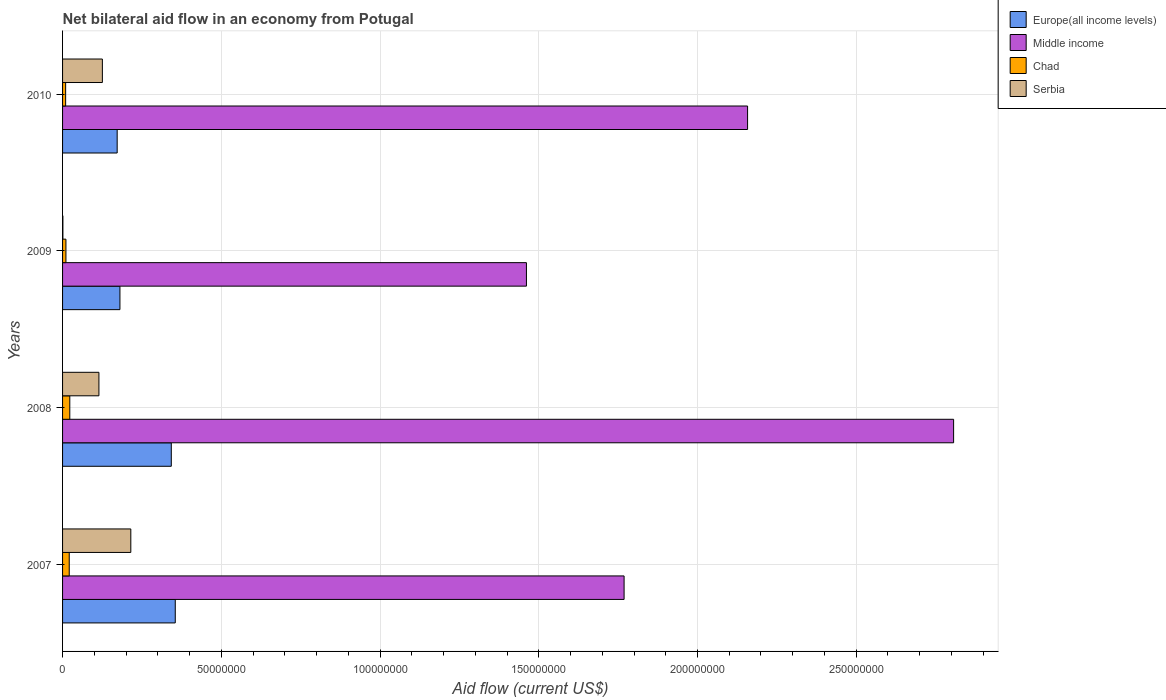Are the number of bars per tick equal to the number of legend labels?
Provide a short and direct response. Yes. How many bars are there on the 4th tick from the bottom?
Make the answer very short. 4. In how many cases, is the number of bars for a given year not equal to the number of legend labels?
Give a very brief answer. 0. What is the net bilateral aid flow in Middle income in 2007?
Make the answer very short. 1.77e+08. Across all years, what is the maximum net bilateral aid flow in Serbia?
Give a very brief answer. 2.15e+07. Across all years, what is the minimum net bilateral aid flow in Serbia?
Make the answer very short. 1.00e+05. In which year was the net bilateral aid flow in Europe(all income levels) maximum?
Ensure brevity in your answer.  2007. What is the total net bilateral aid flow in Serbia in the graph?
Make the answer very short. 4.56e+07. What is the difference between the net bilateral aid flow in Europe(all income levels) in 2007 and that in 2008?
Offer a terse response. 1.25e+06. What is the difference between the net bilateral aid flow in Serbia in 2009 and the net bilateral aid flow in Europe(all income levels) in 2007?
Provide a short and direct response. -3.54e+07. What is the average net bilateral aid flow in Chad per year?
Provide a succinct answer. 1.60e+06. In the year 2009, what is the difference between the net bilateral aid flow in Europe(all income levels) and net bilateral aid flow in Chad?
Provide a succinct answer. 1.70e+07. What is the ratio of the net bilateral aid flow in Europe(all income levels) in 2007 to that in 2009?
Provide a short and direct response. 1.96. Is the net bilateral aid flow in Chad in 2007 less than that in 2010?
Make the answer very short. No. Is the difference between the net bilateral aid flow in Europe(all income levels) in 2007 and 2008 greater than the difference between the net bilateral aid flow in Chad in 2007 and 2008?
Offer a very short reply. Yes. What is the difference between the highest and the second highest net bilateral aid flow in Middle income?
Ensure brevity in your answer.  6.49e+07. What is the difference between the highest and the lowest net bilateral aid flow in Europe(all income levels)?
Your answer should be very brief. 1.83e+07. In how many years, is the net bilateral aid flow in Europe(all income levels) greater than the average net bilateral aid flow in Europe(all income levels) taken over all years?
Your answer should be compact. 2. What does the 2nd bar from the top in 2008 represents?
Your response must be concise. Chad. What does the 2nd bar from the bottom in 2009 represents?
Ensure brevity in your answer.  Middle income. Is it the case that in every year, the sum of the net bilateral aid flow in Chad and net bilateral aid flow in Europe(all income levels) is greater than the net bilateral aid flow in Middle income?
Provide a short and direct response. No. What is the difference between two consecutive major ticks on the X-axis?
Offer a terse response. 5.00e+07. Does the graph contain grids?
Give a very brief answer. Yes. Where does the legend appear in the graph?
Provide a short and direct response. Top right. How are the legend labels stacked?
Provide a succinct answer. Vertical. What is the title of the graph?
Make the answer very short. Net bilateral aid flow in an economy from Potugal. Does "American Samoa" appear as one of the legend labels in the graph?
Your answer should be very brief. No. What is the label or title of the X-axis?
Your answer should be compact. Aid flow (current US$). What is the Aid flow (current US$) of Europe(all income levels) in 2007?
Offer a terse response. 3.55e+07. What is the Aid flow (current US$) in Middle income in 2007?
Offer a terse response. 1.77e+08. What is the Aid flow (current US$) of Chad in 2007?
Give a very brief answer. 2.10e+06. What is the Aid flow (current US$) in Serbia in 2007?
Your answer should be very brief. 2.15e+07. What is the Aid flow (current US$) of Europe(all income levels) in 2008?
Ensure brevity in your answer.  3.42e+07. What is the Aid flow (current US$) of Middle income in 2008?
Give a very brief answer. 2.81e+08. What is the Aid flow (current US$) in Chad in 2008?
Your answer should be compact. 2.28e+06. What is the Aid flow (current US$) in Serbia in 2008?
Offer a terse response. 1.14e+07. What is the Aid flow (current US$) in Europe(all income levels) in 2009?
Offer a terse response. 1.81e+07. What is the Aid flow (current US$) in Middle income in 2009?
Make the answer very short. 1.46e+08. What is the Aid flow (current US$) in Chad in 2009?
Offer a terse response. 1.06e+06. What is the Aid flow (current US$) of Europe(all income levels) in 2010?
Keep it short and to the point. 1.72e+07. What is the Aid flow (current US$) in Middle income in 2010?
Ensure brevity in your answer.  2.16e+08. What is the Aid flow (current US$) in Chad in 2010?
Make the answer very short. 9.70e+05. What is the Aid flow (current US$) in Serbia in 2010?
Your answer should be compact. 1.25e+07. Across all years, what is the maximum Aid flow (current US$) in Europe(all income levels)?
Your answer should be compact. 3.55e+07. Across all years, what is the maximum Aid flow (current US$) of Middle income?
Offer a very short reply. 2.81e+08. Across all years, what is the maximum Aid flow (current US$) in Chad?
Give a very brief answer. 2.28e+06. Across all years, what is the maximum Aid flow (current US$) of Serbia?
Keep it short and to the point. 2.15e+07. Across all years, what is the minimum Aid flow (current US$) in Europe(all income levels)?
Provide a succinct answer. 1.72e+07. Across all years, what is the minimum Aid flow (current US$) of Middle income?
Provide a short and direct response. 1.46e+08. Across all years, what is the minimum Aid flow (current US$) in Chad?
Your response must be concise. 9.70e+05. What is the total Aid flow (current US$) of Europe(all income levels) in the graph?
Your answer should be very brief. 1.05e+08. What is the total Aid flow (current US$) of Middle income in the graph?
Keep it short and to the point. 8.19e+08. What is the total Aid flow (current US$) of Chad in the graph?
Provide a short and direct response. 6.41e+06. What is the total Aid flow (current US$) in Serbia in the graph?
Make the answer very short. 4.56e+07. What is the difference between the Aid flow (current US$) in Europe(all income levels) in 2007 and that in 2008?
Your answer should be compact. 1.25e+06. What is the difference between the Aid flow (current US$) of Middle income in 2007 and that in 2008?
Give a very brief answer. -1.04e+08. What is the difference between the Aid flow (current US$) in Serbia in 2007 and that in 2008?
Your answer should be very brief. 1.00e+07. What is the difference between the Aid flow (current US$) of Europe(all income levels) in 2007 and that in 2009?
Make the answer very short. 1.74e+07. What is the difference between the Aid flow (current US$) in Middle income in 2007 and that in 2009?
Your answer should be compact. 3.08e+07. What is the difference between the Aid flow (current US$) in Chad in 2007 and that in 2009?
Keep it short and to the point. 1.04e+06. What is the difference between the Aid flow (current US$) in Serbia in 2007 and that in 2009?
Offer a very short reply. 2.14e+07. What is the difference between the Aid flow (current US$) of Europe(all income levels) in 2007 and that in 2010?
Your answer should be very brief. 1.83e+07. What is the difference between the Aid flow (current US$) in Middle income in 2007 and that in 2010?
Offer a terse response. -3.89e+07. What is the difference between the Aid flow (current US$) in Chad in 2007 and that in 2010?
Ensure brevity in your answer.  1.13e+06. What is the difference between the Aid flow (current US$) in Serbia in 2007 and that in 2010?
Your answer should be very brief. 8.96e+06. What is the difference between the Aid flow (current US$) in Europe(all income levels) in 2008 and that in 2009?
Keep it short and to the point. 1.62e+07. What is the difference between the Aid flow (current US$) in Middle income in 2008 and that in 2009?
Ensure brevity in your answer.  1.35e+08. What is the difference between the Aid flow (current US$) in Chad in 2008 and that in 2009?
Your answer should be very brief. 1.22e+06. What is the difference between the Aid flow (current US$) of Serbia in 2008 and that in 2009?
Make the answer very short. 1.14e+07. What is the difference between the Aid flow (current US$) in Europe(all income levels) in 2008 and that in 2010?
Give a very brief answer. 1.70e+07. What is the difference between the Aid flow (current US$) in Middle income in 2008 and that in 2010?
Your answer should be compact. 6.49e+07. What is the difference between the Aid flow (current US$) of Chad in 2008 and that in 2010?
Provide a succinct answer. 1.31e+06. What is the difference between the Aid flow (current US$) in Serbia in 2008 and that in 2010?
Provide a succinct answer. -1.09e+06. What is the difference between the Aid flow (current US$) of Europe(all income levels) in 2009 and that in 2010?
Make the answer very short. 8.70e+05. What is the difference between the Aid flow (current US$) of Middle income in 2009 and that in 2010?
Your response must be concise. -6.97e+07. What is the difference between the Aid flow (current US$) in Chad in 2009 and that in 2010?
Your answer should be compact. 9.00e+04. What is the difference between the Aid flow (current US$) in Serbia in 2009 and that in 2010?
Your answer should be compact. -1.24e+07. What is the difference between the Aid flow (current US$) of Europe(all income levels) in 2007 and the Aid flow (current US$) of Middle income in 2008?
Provide a succinct answer. -2.45e+08. What is the difference between the Aid flow (current US$) of Europe(all income levels) in 2007 and the Aid flow (current US$) of Chad in 2008?
Your answer should be compact. 3.32e+07. What is the difference between the Aid flow (current US$) of Europe(all income levels) in 2007 and the Aid flow (current US$) of Serbia in 2008?
Give a very brief answer. 2.40e+07. What is the difference between the Aid flow (current US$) of Middle income in 2007 and the Aid flow (current US$) of Chad in 2008?
Your answer should be compact. 1.75e+08. What is the difference between the Aid flow (current US$) in Middle income in 2007 and the Aid flow (current US$) in Serbia in 2008?
Your answer should be very brief. 1.65e+08. What is the difference between the Aid flow (current US$) in Chad in 2007 and the Aid flow (current US$) in Serbia in 2008?
Make the answer very short. -9.35e+06. What is the difference between the Aid flow (current US$) of Europe(all income levels) in 2007 and the Aid flow (current US$) of Middle income in 2009?
Keep it short and to the point. -1.11e+08. What is the difference between the Aid flow (current US$) in Europe(all income levels) in 2007 and the Aid flow (current US$) in Chad in 2009?
Give a very brief answer. 3.44e+07. What is the difference between the Aid flow (current US$) in Europe(all income levels) in 2007 and the Aid flow (current US$) in Serbia in 2009?
Give a very brief answer. 3.54e+07. What is the difference between the Aid flow (current US$) in Middle income in 2007 and the Aid flow (current US$) in Chad in 2009?
Keep it short and to the point. 1.76e+08. What is the difference between the Aid flow (current US$) in Middle income in 2007 and the Aid flow (current US$) in Serbia in 2009?
Provide a short and direct response. 1.77e+08. What is the difference between the Aid flow (current US$) of Chad in 2007 and the Aid flow (current US$) of Serbia in 2009?
Make the answer very short. 2.00e+06. What is the difference between the Aid flow (current US$) of Europe(all income levels) in 2007 and the Aid flow (current US$) of Middle income in 2010?
Your response must be concise. -1.80e+08. What is the difference between the Aid flow (current US$) in Europe(all income levels) in 2007 and the Aid flow (current US$) in Chad in 2010?
Give a very brief answer. 3.45e+07. What is the difference between the Aid flow (current US$) in Europe(all income levels) in 2007 and the Aid flow (current US$) in Serbia in 2010?
Ensure brevity in your answer.  2.30e+07. What is the difference between the Aid flow (current US$) in Middle income in 2007 and the Aid flow (current US$) in Chad in 2010?
Offer a terse response. 1.76e+08. What is the difference between the Aid flow (current US$) of Middle income in 2007 and the Aid flow (current US$) of Serbia in 2010?
Offer a very short reply. 1.64e+08. What is the difference between the Aid flow (current US$) in Chad in 2007 and the Aid flow (current US$) in Serbia in 2010?
Your response must be concise. -1.04e+07. What is the difference between the Aid flow (current US$) in Europe(all income levels) in 2008 and the Aid flow (current US$) in Middle income in 2009?
Offer a very short reply. -1.12e+08. What is the difference between the Aid flow (current US$) in Europe(all income levels) in 2008 and the Aid flow (current US$) in Chad in 2009?
Your answer should be compact. 3.32e+07. What is the difference between the Aid flow (current US$) of Europe(all income levels) in 2008 and the Aid flow (current US$) of Serbia in 2009?
Give a very brief answer. 3.42e+07. What is the difference between the Aid flow (current US$) in Middle income in 2008 and the Aid flow (current US$) in Chad in 2009?
Make the answer very short. 2.80e+08. What is the difference between the Aid flow (current US$) of Middle income in 2008 and the Aid flow (current US$) of Serbia in 2009?
Provide a succinct answer. 2.81e+08. What is the difference between the Aid flow (current US$) of Chad in 2008 and the Aid flow (current US$) of Serbia in 2009?
Provide a succinct answer. 2.18e+06. What is the difference between the Aid flow (current US$) of Europe(all income levels) in 2008 and the Aid flow (current US$) of Middle income in 2010?
Keep it short and to the point. -1.82e+08. What is the difference between the Aid flow (current US$) of Europe(all income levels) in 2008 and the Aid flow (current US$) of Chad in 2010?
Your response must be concise. 3.33e+07. What is the difference between the Aid flow (current US$) of Europe(all income levels) in 2008 and the Aid flow (current US$) of Serbia in 2010?
Keep it short and to the point. 2.17e+07. What is the difference between the Aid flow (current US$) in Middle income in 2008 and the Aid flow (current US$) in Chad in 2010?
Give a very brief answer. 2.80e+08. What is the difference between the Aid flow (current US$) of Middle income in 2008 and the Aid flow (current US$) of Serbia in 2010?
Make the answer very short. 2.68e+08. What is the difference between the Aid flow (current US$) of Chad in 2008 and the Aid flow (current US$) of Serbia in 2010?
Your response must be concise. -1.03e+07. What is the difference between the Aid flow (current US$) of Europe(all income levels) in 2009 and the Aid flow (current US$) of Middle income in 2010?
Your answer should be compact. -1.98e+08. What is the difference between the Aid flow (current US$) of Europe(all income levels) in 2009 and the Aid flow (current US$) of Chad in 2010?
Provide a succinct answer. 1.71e+07. What is the difference between the Aid flow (current US$) in Europe(all income levels) in 2009 and the Aid flow (current US$) in Serbia in 2010?
Provide a short and direct response. 5.53e+06. What is the difference between the Aid flow (current US$) in Middle income in 2009 and the Aid flow (current US$) in Chad in 2010?
Offer a very short reply. 1.45e+08. What is the difference between the Aid flow (current US$) in Middle income in 2009 and the Aid flow (current US$) in Serbia in 2010?
Make the answer very short. 1.34e+08. What is the difference between the Aid flow (current US$) in Chad in 2009 and the Aid flow (current US$) in Serbia in 2010?
Your response must be concise. -1.15e+07. What is the average Aid flow (current US$) in Europe(all income levels) per year?
Offer a very short reply. 2.63e+07. What is the average Aid flow (current US$) in Middle income per year?
Your answer should be very brief. 2.05e+08. What is the average Aid flow (current US$) of Chad per year?
Offer a very short reply. 1.60e+06. What is the average Aid flow (current US$) of Serbia per year?
Provide a succinct answer. 1.14e+07. In the year 2007, what is the difference between the Aid flow (current US$) of Europe(all income levels) and Aid flow (current US$) of Middle income?
Give a very brief answer. -1.41e+08. In the year 2007, what is the difference between the Aid flow (current US$) of Europe(all income levels) and Aid flow (current US$) of Chad?
Give a very brief answer. 3.34e+07. In the year 2007, what is the difference between the Aid flow (current US$) of Europe(all income levels) and Aid flow (current US$) of Serbia?
Your answer should be compact. 1.40e+07. In the year 2007, what is the difference between the Aid flow (current US$) in Middle income and Aid flow (current US$) in Chad?
Keep it short and to the point. 1.75e+08. In the year 2007, what is the difference between the Aid flow (current US$) of Middle income and Aid flow (current US$) of Serbia?
Ensure brevity in your answer.  1.55e+08. In the year 2007, what is the difference between the Aid flow (current US$) in Chad and Aid flow (current US$) in Serbia?
Keep it short and to the point. -1.94e+07. In the year 2008, what is the difference between the Aid flow (current US$) in Europe(all income levels) and Aid flow (current US$) in Middle income?
Your answer should be very brief. -2.46e+08. In the year 2008, what is the difference between the Aid flow (current US$) of Europe(all income levels) and Aid flow (current US$) of Chad?
Offer a very short reply. 3.20e+07. In the year 2008, what is the difference between the Aid flow (current US$) in Europe(all income levels) and Aid flow (current US$) in Serbia?
Make the answer very short. 2.28e+07. In the year 2008, what is the difference between the Aid flow (current US$) in Middle income and Aid flow (current US$) in Chad?
Your answer should be compact. 2.78e+08. In the year 2008, what is the difference between the Aid flow (current US$) of Middle income and Aid flow (current US$) of Serbia?
Give a very brief answer. 2.69e+08. In the year 2008, what is the difference between the Aid flow (current US$) of Chad and Aid flow (current US$) of Serbia?
Ensure brevity in your answer.  -9.17e+06. In the year 2009, what is the difference between the Aid flow (current US$) in Europe(all income levels) and Aid flow (current US$) in Middle income?
Keep it short and to the point. -1.28e+08. In the year 2009, what is the difference between the Aid flow (current US$) of Europe(all income levels) and Aid flow (current US$) of Chad?
Your answer should be very brief. 1.70e+07. In the year 2009, what is the difference between the Aid flow (current US$) in Europe(all income levels) and Aid flow (current US$) in Serbia?
Your response must be concise. 1.80e+07. In the year 2009, what is the difference between the Aid flow (current US$) of Middle income and Aid flow (current US$) of Chad?
Your answer should be compact. 1.45e+08. In the year 2009, what is the difference between the Aid flow (current US$) of Middle income and Aid flow (current US$) of Serbia?
Your answer should be compact. 1.46e+08. In the year 2009, what is the difference between the Aid flow (current US$) of Chad and Aid flow (current US$) of Serbia?
Keep it short and to the point. 9.60e+05. In the year 2010, what is the difference between the Aid flow (current US$) of Europe(all income levels) and Aid flow (current US$) of Middle income?
Offer a very short reply. -1.99e+08. In the year 2010, what is the difference between the Aid flow (current US$) of Europe(all income levels) and Aid flow (current US$) of Chad?
Provide a short and direct response. 1.62e+07. In the year 2010, what is the difference between the Aid flow (current US$) in Europe(all income levels) and Aid flow (current US$) in Serbia?
Offer a very short reply. 4.66e+06. In the year 2010, what is the difference between the Aid flow (current US$) of Middle income and Aid flow (current US$) of Chad?
Ensure brevity in your answer.  2.15e+08. In the year 2010, what is the difference between the Aid flow (current US$) in Middle income and Aid flow (current US$) in Serbia?
Keep it short and to the point. 2.03e+08. In the year 2010, what is the difference between the Aid flow (current US$) of Chad and Aid flow (current US$) of Serbia?
Offer a terse response. -1.16e+07. What is the ratio of the Aid flow (current US$) in Europe(all income levels) in 2007 to that in 2008?
Make the answer very short. 1.04. What is the ratio of the Aid flow (current US$) in Middle income in 2007 to that in 2008?
Ensure brevity in your answer.  0.63. What is the ratio of the Aid flow (current US$) of Chad in 2007 to that in 2008?
Provide a short and direct response. 0.92. What is the ratio of the Aid flow (current US$) in Serbia in 2007 to that in 2008?
Ensure brevity in your answer.  1.88. What is the ratio of the Aid flow (current US$) in Europe(all income levels) in 2007 to that in 2009?
Your response must be concise. 1.96. What is the ratio of the Aid flow (current US$) of Middle income in 2007 to that in 2009?
Make the answer very short. 1.21. What is the ratio of the Aid flow (current US$) of Chad in 2007 to that in 2009?
Your answer should be compact. 1.98. What is the ratio of the Aid flow (current US$) in Serbia in 2007 to that in 2009?
Your answer should be very brief. 215. What is the ratio of the Aid flow (current US$) of Europe(all income levels) in 2007 to that in 2010?
Your response must be concise. 2.06. What is the ratio of the Aid flow (current US$) in Middle income in 2007 to that in 2010?
Keep it short and to the point. 0.82. What is the ratio of the Aid flow (current US$) in Chad in 2007 to that in 2010?
Your answer should be very brief. 2.16. What is the ratio of the Aid flow (current US$) of Serbia in 2007 to that in 2010?
Keep it short and to the point. 1.71. What is the ratio of the Aid flow (current US$) of Europe(all income levels) in 2008 to that in 2009?
Ensure brevity in your answer.  1.9. What is the ratio of the Aid flow (current US$) in Middle income in 2008 to that in 2009?
Your response must be concise. 1.92. What is the ratio of the Aid flow (current US$) in Chad in 2008 to that in 2009?
Provide a succinct answer. 2.15. What is the ratio of the Aid flow (current US$) in Serbia in 2008 to that in 2009?
Your answer should be very brief. 114.5. What is the ratio of the Aid flow (current US$) of Europe(all income levels) in 2008 to that in 2010?
Provide a succinct answer. 1.99. What is the ratio of the Aid flow (current US$) in Middle income in 2008 to that in 2010?
Give a very brief answer. 1.3. What is the ratio of the Aid flow (current US$) of Chad in 2008 to that in 2010?
Your answer should be very brief. 2.35. What is the ratio of the Aid flow (current US$) in Serbia in 2008 to that in 2010?
Provide a succinct answer. 0.91. What is the ratio of the Aid flow (current US$) in Europe(all income levels) in 2009 to that in 2010?
Make the answer very short. 1.05. What is the ratio of the Aid flow (current US$) in Middle income in 2009 to that in 2010?
Offer a terse response. 0.68. What is the ratio of the Aid flow (current US$) in Chad in 2009 to that in 2010?
Provide a succinct answer. 1.09. What is the ratio of the Aid flow (current US$) in Serbia in 2009 to that in 2010?
Your response must be concise. 0.01. What is the difference between the highest and the second highest Aid flow (current US$) of Europe(all income levels)?
Your response must be concise. 1.25e+06. What is the difference between the highest and the second highest Aid flow (current US$) of Middle income?
Your answer should be compact. 6.49e+07. What is the difference between the highest and the second highest Aid flow (current US$) in Chad?
Your answer should be very brief. 1.80e+05. What is the difference between the highest and the second highest Aid flow (current US$) of Serbia?
Keep it short and to the point. 8.96e+06. What is the difference between the highest and the lowest Aid flow (current US$) of Europe(all income levels)?
Your answer should be very brief. 1.83e+07. What is the difference between the highest and the lowest Aid flow (current US$) in Middle income?
Make the answer very short. 1.35e+08. What is the difference between the highest and the lowest Aid flow (current US$) of Chad?
Offer a terse response. 1.31e+06. What is the difference between the highest and the lowest Aid flow (current US$) in Serbia?
Ensure brevity in your answer.  2.14e+07. 